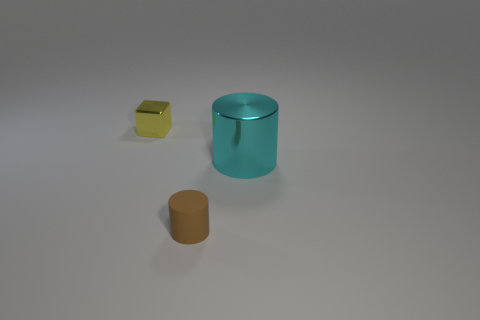Add 1 small yellow blocks. How many objects exist? 4 Subtract all blocks. How many objects are left? 2 Add 2 big cyan shiny cylinders. How many big cyan shiny cylinders are left? 3 Add 3 tiny green rubber things. How many tiny green rubber things exist? 3 Subtract 0 purple cylinders. How many objects are left? 3 Subtract all big purple matte cylinders. Subtract all small yellow blocks. How many objects are left? 2 